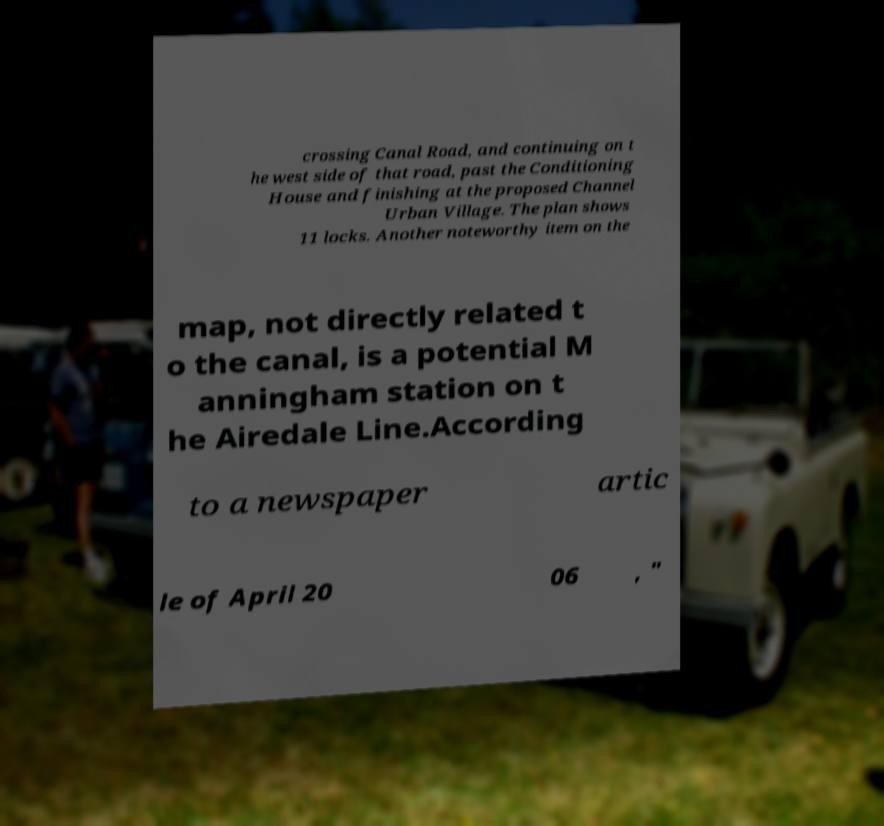Can you accurately transcribe the text from the provided image for me? crossing Canal Road, and continuing on t he west side of that road, past the Conditioning House and finishing at the proposed Channel Urban Village. The plan shows 11 locks. Another noteworthy item on the map, not directly related t o the canal, is a potential M anningham station on t he Airedale Line.According to a newspaper artic le of April 20 06 , " 